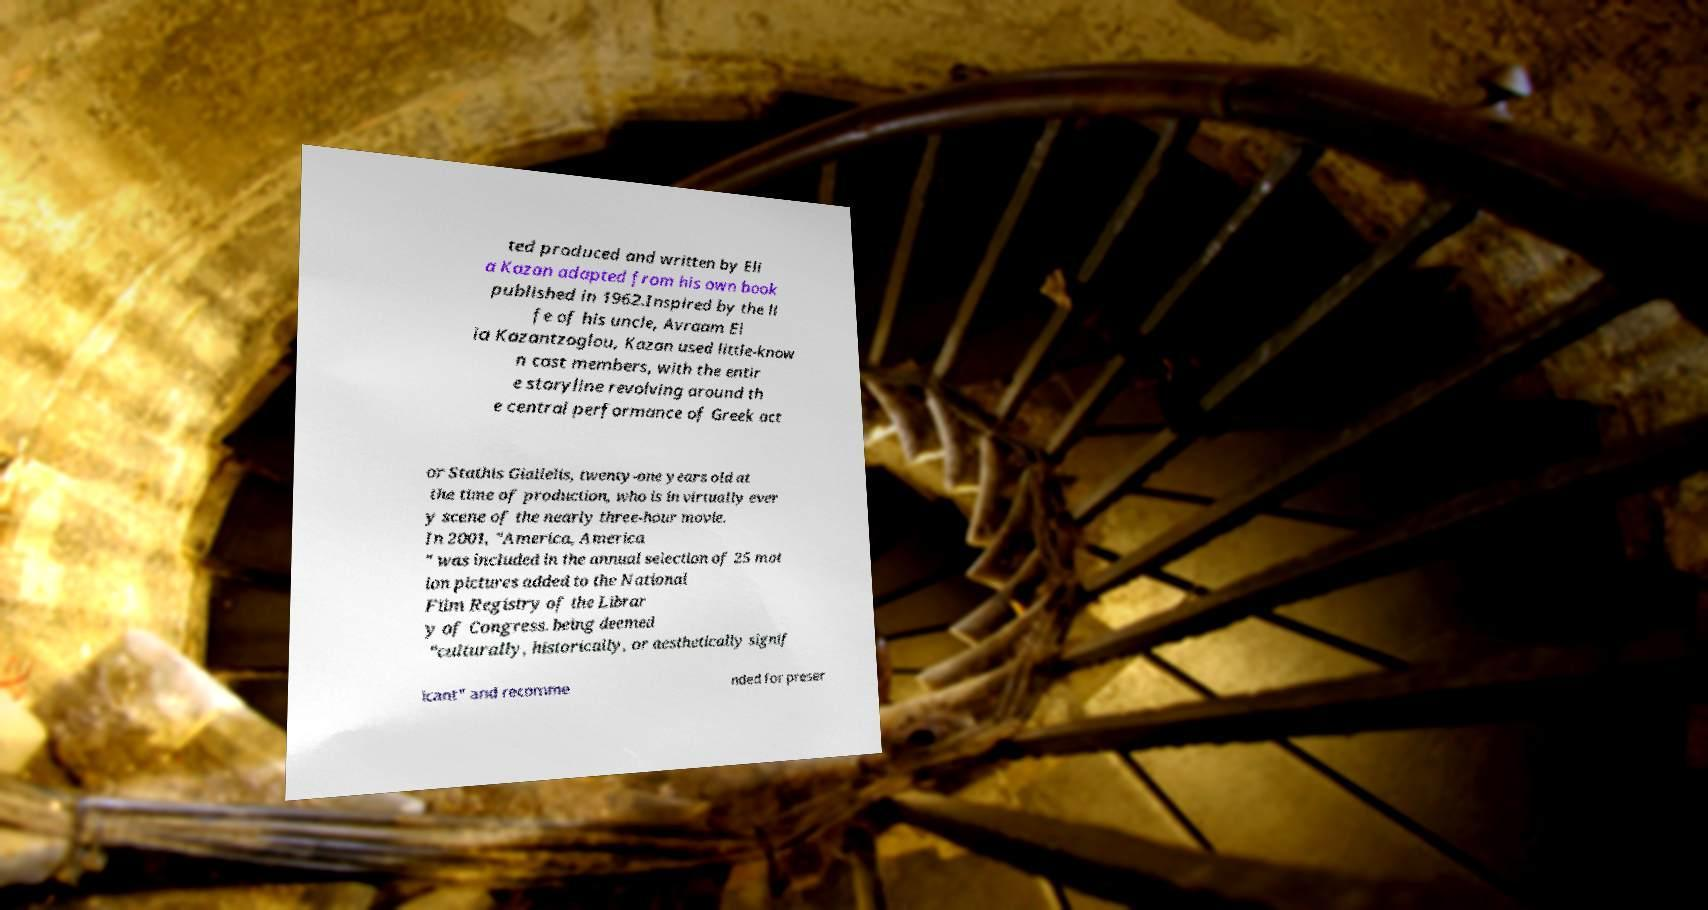Could you assist in decoding the text presented in this image and type it out clearly? ted produced and written by Eli a Kazan adapted from his own book published in 1962.Inspired by the li fe of his uncle, Avraam El ia Kazantzoglou, Kazan used little-know n cast members, with the entir e storyline revolving around th e central performance of Greek act or Stathis Giallelis, twenty-one years old at the time of production, who is in virtually ever y scene of the nearly three-hour movie. In 2001, "America, America " was included in the annual selection of 25 mot ion pictures added to the National Film Registry of the Librar y of Congress. being deemed "culturally, historically, or aesthetically signif icant" and recomme nded for preser 